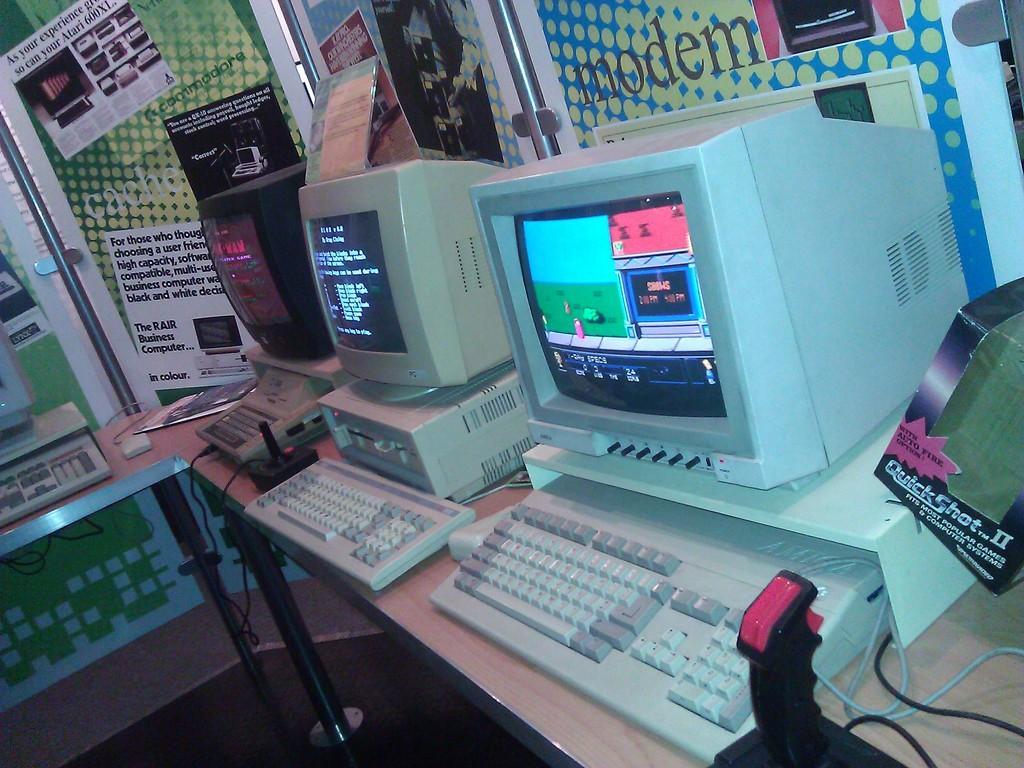Can you describe this image briefly? In the foreground of the image, there are three computers, a cardboard box, posters, black color objects on the table. Behind it, there is a banner wall and also a computer on the table, on the left. 